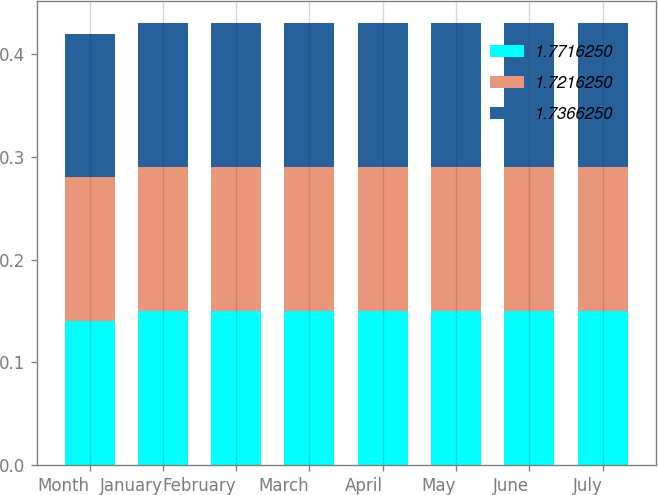Convert chart to OTSL. <chart><loc_0><loc_0><loc_500><loc_500><stacked_bar_chart><ecel><fcel>Month<fcel>January<fcel>February<fcel>March<fcel>April<fcel>May<fcel>June<fcel>July<nl><fcel>1.77163<fcel>0.14<fcel>0.15<fcel>0.15<fcel>0.15<fcel>0.15<fcel>0.15<fcel>0.15<fcel>0.15<nl><fcel>1.72162<fcel>0.14<fcel>0.14<fcel>0.14<fcel>0.14<fcel>0.14<fcel>0.14<fcel>0.14<fcel>0.14<nl><fcel>1.73663<fcel>0.14<fcel>0.14<fcel>0.14<fcel>0.14<fcel>0.14<fcel>0.14<fcel>0.14<fcel>0.14<nl></chart> 